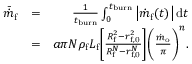Convert formula to latex. <formula><loc_0><loc_0><loc_500><loc_500>\begin{array} { r l r } { \bar { \dot { m } } _ { f } } & { = } & { \frac { 1 } { t _ { b u r n } } \int _ { 0 } ^ { t _ { b u r n } } \left | \dot { m } _ { f } ( t ) \right | d t } \\ & { = } & { a \pi N \rho _ { f } L _ { f } \left [ \frac { R _ { f } ^ { 2 } - r _ { f , 0 } ^ { 2 } } { R _ { f } ^ { N } - r _ { f , 0 } ^ { N } } \right ] \left ( \frac { \dot { m } _ { o } } { \pi } \right ) ^ { n } . } \end{array}</formula> 